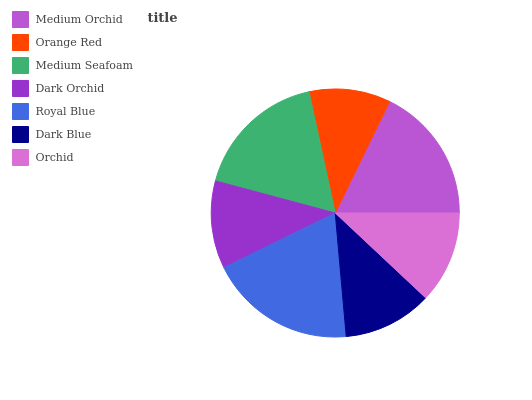Is Orange Red the minimum?
Answer yes or no. Yes. Is Royal Blue the maximum?
Answer yes or no. Yes. Is Medium Seafoam the minimum?
Answer yes or no. No. Is Medium Seafoam the maximum?
Answer yes or no. No. Is Medium Seafoam greater than Orange Red?
Answer yes or no. Yes. Is Orange Red less than Medium Seafoam?
Answer yes or no. Yes. Is Orange Red greater than Medium Seafoam?
Answer yes or no. No. Is Medium Seafoam less than Orange Red?
Answer yes or no. No. Is Orchid the high median?
Answer yes or no. Yes. Is Orchid the low median?
Answer yes or no. Yes. Is Dark Orchid the high median?
Answer yes or no. No. Is Dark Orchid the low median?
Answer yes or no. No. 